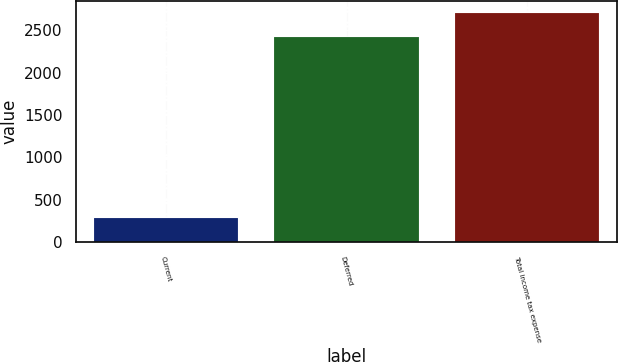<chart> <loc_0><loc_0><loc_500><loc_500><bar_chart><fcel>Current<fcel>Deferred<fcel>Total income tax expense<nl><fcel>283<fcel>2422<fcel>2705<nl></chart> 